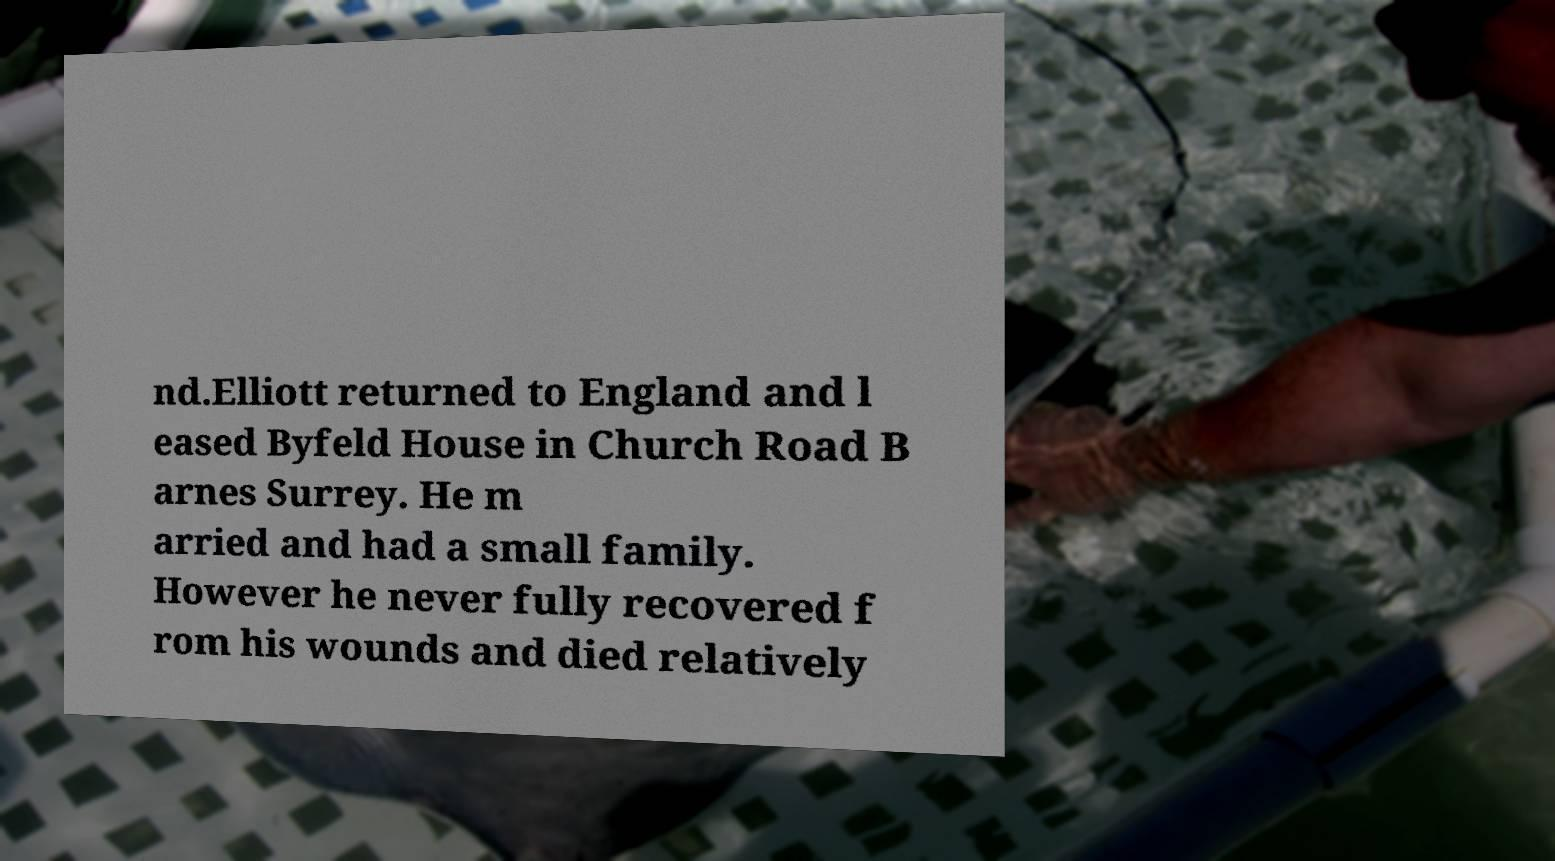Please read and relay the text visible in this image. What does it say? nd.Elliott returned to England and l eased Byfeld House in Church Road B arnes Surrey. He m arried and had a small family. However he never fully recovered f rom his wounds and died relatively 